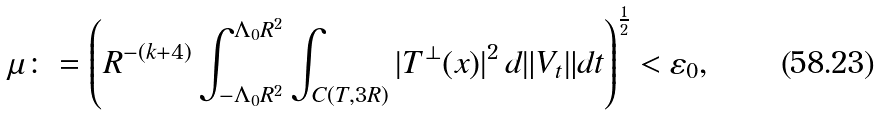Convert formula to latex. <formula><loc_0><loc_0><loc_500><loc_500>\mu \colon = \left ( R ^ { - ( k + 4 ) } \int _ { - \Lambda _ { 0 } R ^ { 2 } } ^ { \Lambda _ { 0 } R ^ { 2 } } \int _ { C ( T , 3 R ) } | T ^ { \perp } ( x ) | ^ { 2 } \, d \| V _ { t } \| d t \right ) ^ { \frac { 1 } { 2 } } < \varepsilon _ { 0 } ,</formula> 